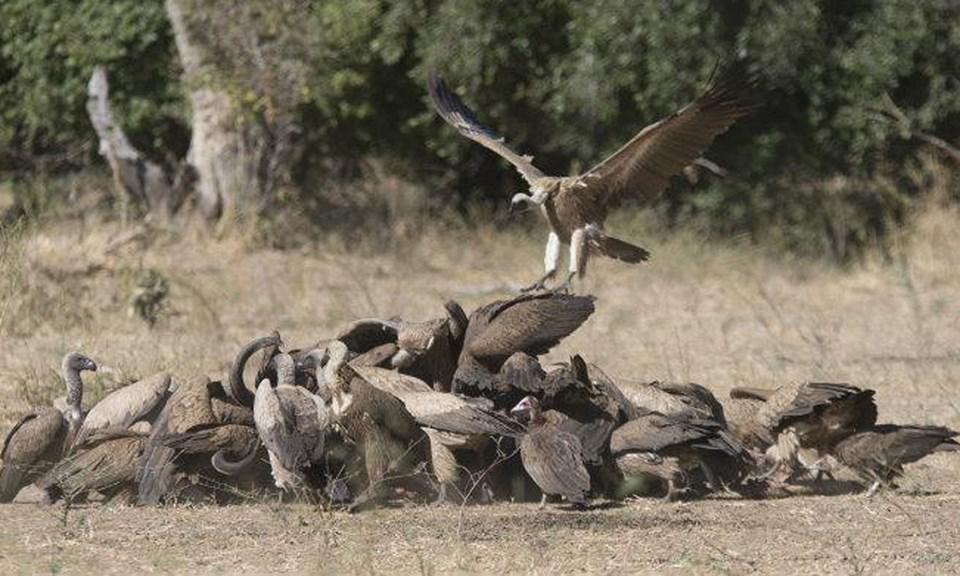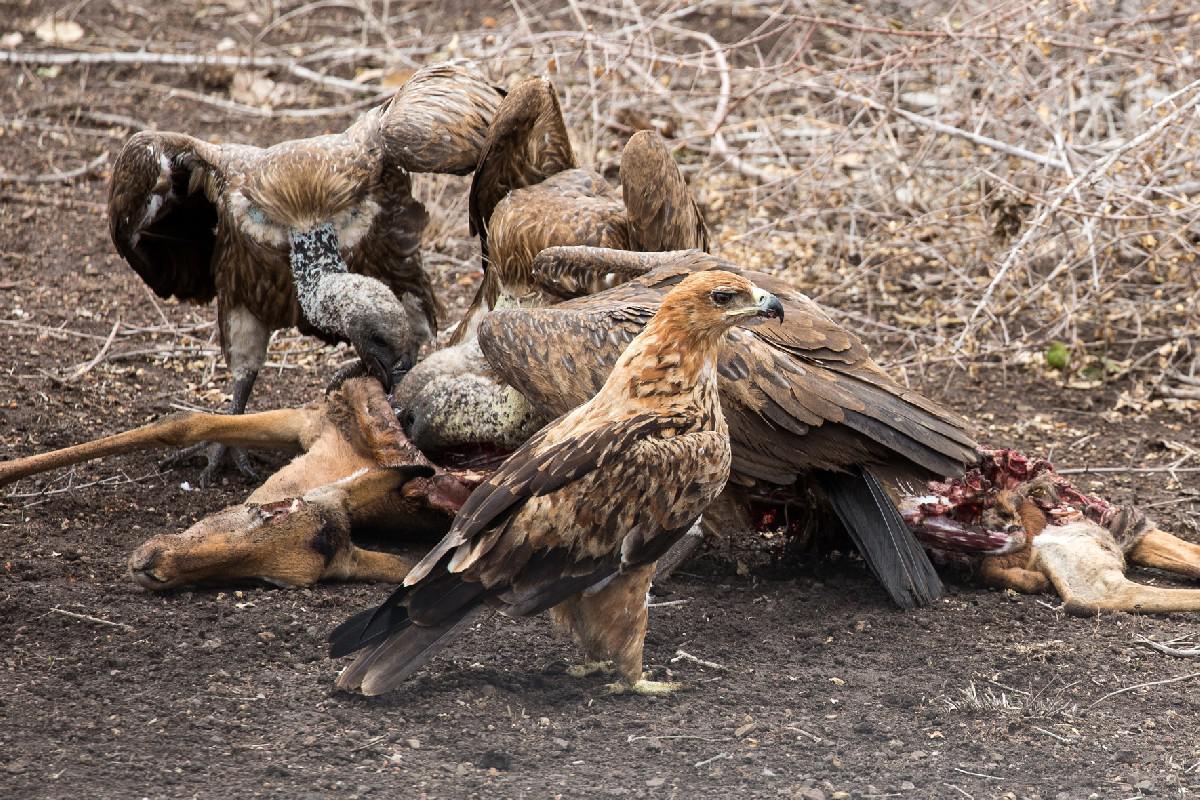The first image is the image on the left, the second image is the image on the right. Analyze the images presented: Is the assertion "There are at least eight vultures eating a dead animal who is horns are visible." valid? Answer yes or no. Yes. The first image is the image on the left, the second image is the image on the right. Evaluate the accuracy of this statement regarding the images: "In one of the images, the carrion birds are NOT eating anything at the moment.". Is it true? Answer yes or no. No. 